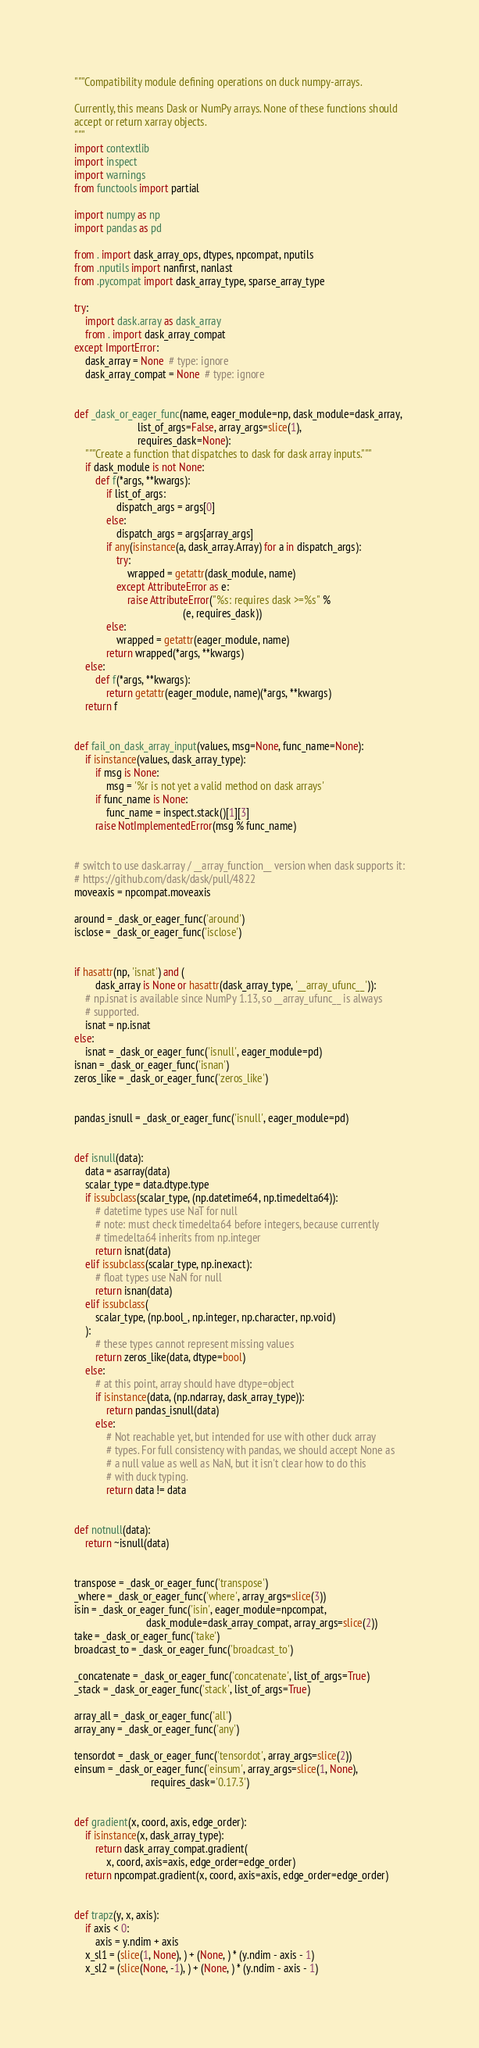Convert code to text. <code><loc_0><loc_0><loc_500><loc_500><_Python_>"""Compatibility module defining operations on duck numpy-arrays.

Currently, this means Dask or NumPy arrays. None of these functions should
accept or return xarray objects.
"""
import contextlib
import inspect
import warnings
from functools import partial

import numpy as np
import pandas as pd

from . import dask_array_ops, dtypes, npcompat, nputils
from .nputils import nanfirst, nanlast
from .pycompat import dask_array_type, sparse_array_type

try:
    import dask.array as dask_array
    from . import dask_array_compat
except ImportError:
    dask_array = None  # type: ignore
    dask_array_compat = None  # type: ignore


def _dask_or_eager_func(name, eager_module=np, dask_module=dask_array,
                        list_of_args=False, array_args=slice(1),
                        requires_dask=None):
    """Create a function that dispatches to dask for dask array inputs."""
    if dask_module is not None:
        def f(*args, **kwargs):
            if list_of_args:
                dispatch_args = args[0]
            else:
                dispatch_args = args[array_args]
            if any(isinstance(a, dask_array.Array) for a in dispatch_args):
                try:
                    wrapped = getattr(dask_module, name)
                except AttributeError as e:
                    raise AttributeError("%s: requires dask >=%s" %
                                         (e, requires_dask))
            else:
                wrapped = getattr(eager_module, name)
            return wrapped(*args, **kwargs)
    else:
        def f(*args, **kwargs):
            return getattr(eager_module, name)(*args, **kwargs)
    return f


def fail_on_dask_array_input(values, msg=None, func_name=None):
    if isinstance(values, dask_array_type):
        if msg is None:
            msg = '%r is not yet a valid method on dask arrays'
        if func_name is None:
            func_name = inspect.stack()[1][3]
        raise NotImplementedError(msg % func_name)


# switch to use dask.array / __array_function__ version when dask supports it:
# https://github.com/dask/dask/pull/4822
moveaxis = npcompat.moveaxis

around = _dask_or_eager_func('around')
isclose = _dask_or_eager_func('isclose')


if hasattr(np, 'isnat') and (
        dask_array is None or hasattr(dask_array_type, '__array_ufunc__')):
    # np.isnat is available since NumPy 1.13, so __array_ufunc__ is always
    # supported.
    isnat = np.isnat
else:
    isnat = _dask_or_eager_func('isnull', eager_module=pd)
isnan = _dask_or_eager_func('isnan')
zeros_like = _dask_or_eager_func('zeros_like')


pandas_isnull = _dask_or_eager_func('isnull', eager_module=pd)


def isnull(data):
    data = asarray(data)
    scalar_type = data.dtype.type
    if issubclass(scalar_type, (np.datetime64, np.timedelta64)):
        # datetime types use NaT for null
        # note: must check timedelta64 before integers, because currently
        # timedelta64 inherits from np.integer
        return isnat(data)
    elif issubclass(scalar_type, np.inexact):
        # float types use NaN for null
        return isnan(data)
    elif issubclass(
        scalar_type, (np.bool_, np.integer, np.character, np.void)
    ):
        # these types cannot represent missing values
        return zeros_like(data, dtype=bool)
    else:
        # at this point, array should have dtype=object
        if isinstance(data, (np.ndarray, dask_array_type)):
            return pandas_isnull(data)
        else:
            # Not reachable yet, but intended for use with other duck array
            # types. For full consistency with pandas, we should accept None as
            # a null value as well as NaN, but it isn't clear how to do this
            # with duck typing.
            return data != data


def notnull(data):
    return ~isnull(data)


transpose = _dask_or_eager_func('transpose')
_where = _dask_or_eager_func('where', array_args=slice(3))
isin = _dask_or_eager_func('isin', eager_module=npcompat,
                           dask_module=dask_array_compat, array_args=slice(2))
take = _dask_or_eager_func('take')
broadcast_to = _dask_or_eager_func('broadcast_to')

_concatenate = _dask_or_eager_func('concatenate', list_of_args=True)
_stack = _dask_or_eager_func('stack', list_of_args=True)

array_all = _dask_or_eager_func('all')
array_any = _dask_or_eager_func('any')

tensordot = _dask_or_eager_func('tensordot', array_args=slice(2))
einsum = _dask_or_eager_func('einsum', array_args=slice(1, None),
                             requires_dask='0.17.3')


def gradient(x, coord, axis, edge_order):
    if isinstance(x, dask_array_type):
        return dask_array_compat.gradient(
            x, coord, axis=axis, edge_order=edge_order)
    return npcompat.gradient(x, coord, axis=axis, edge_order=edge_order)


def trapz(y, x, axis):
    if axis < 0:
        axis = y.ndim + axis
    x_sl1 = (slice(1, None), ) + (None, ) * (y.ndim - axis - 1)
    x_sl2 = (slice(None, -1), ) + (None, ) * (y.ndim - axis - 1)</code> 